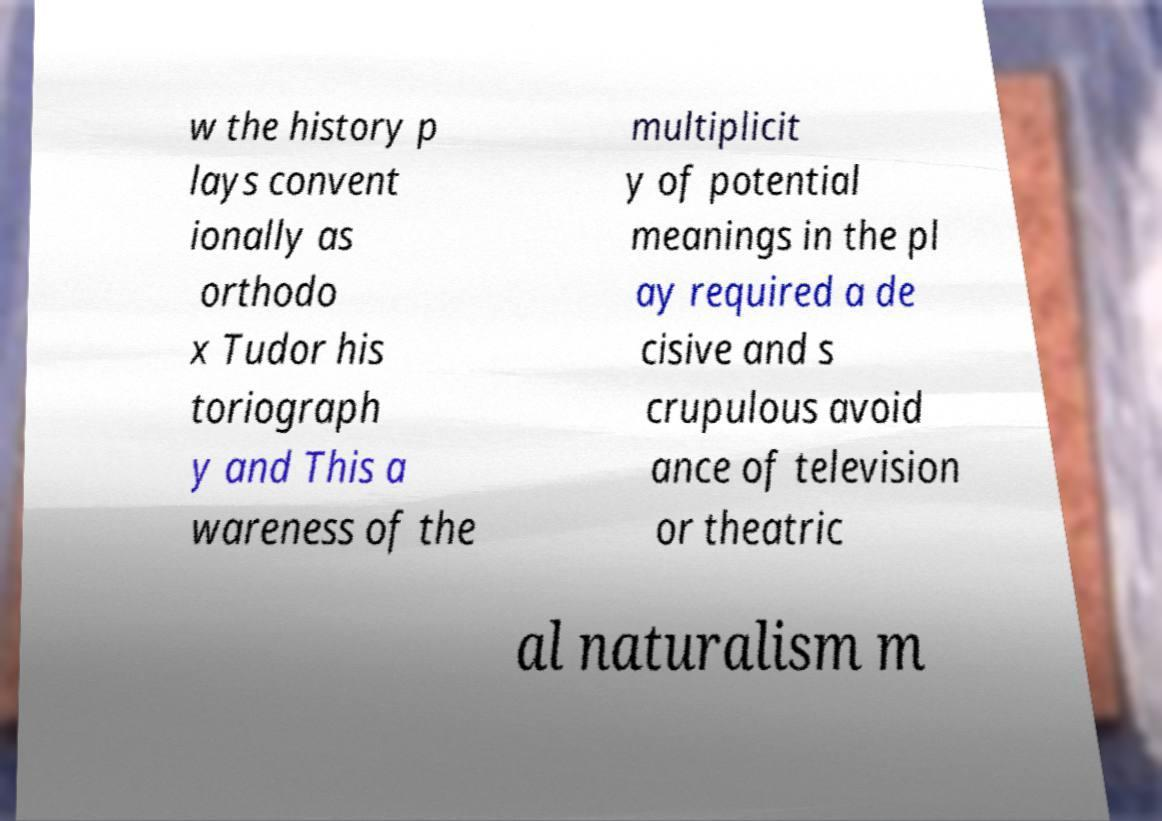What messages or text are displayed in this image? I need them in a readable, typed format. w the history p lays convent ionally as orthodo x Tudor his toriograph y and This a wareness of the multiplicit y of potential meanings in the pl ay required a de cisive and s crupulous avoid ance of television or theatric al naturalism m 